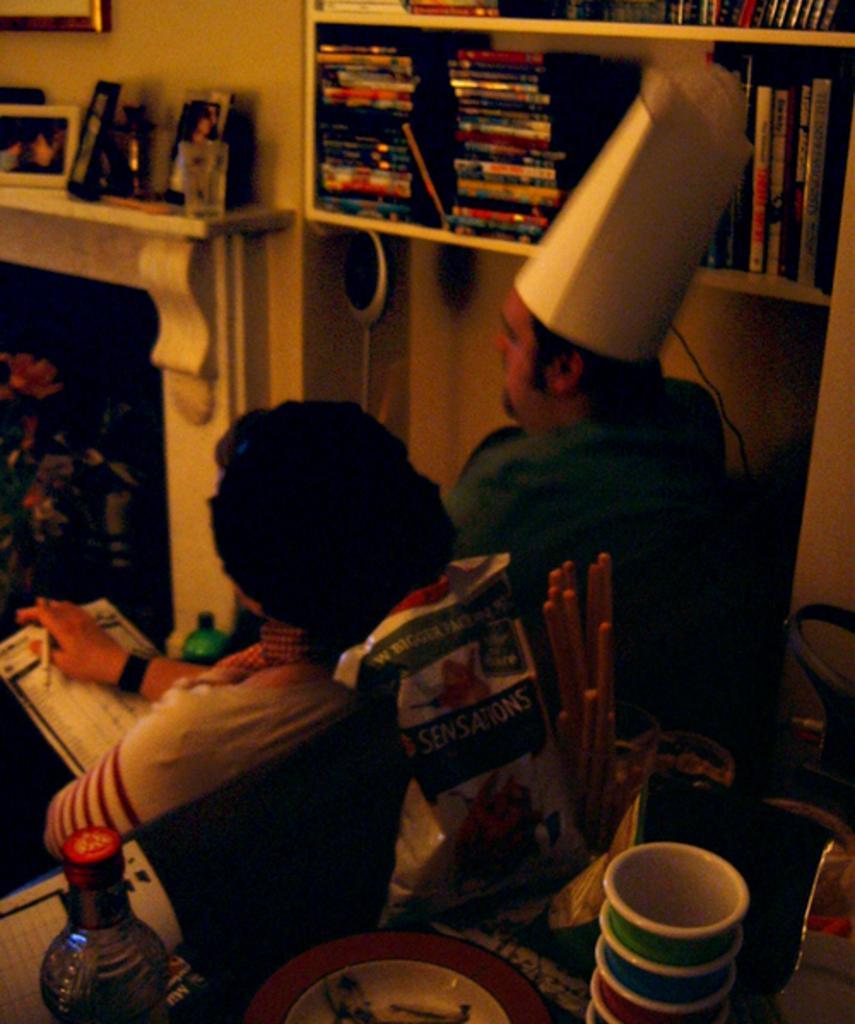Describe this image in one or two sentences. In this image in front there is a table and on top of the table there are cups, plate, bottle and few other objects. There are two people sitting on the chairs. Beside them there are books in the shelf's. On the left side of the image there are plants. There is a fire place and on top of it there are photo frames. In the background of the image there is a wall with the photo frame on it. 